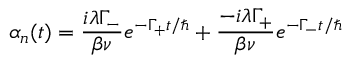<formula> <loc_0><loc_0><loc_500><loc_500>\alpha _ { n } ( t ) = \frac { i \lambda \Gamma _ { - } } { \beta \nu } e ^ { - \Gamma _ { + } t / } + \frac { - i \lambda \Gamma _ { + } } { \beta \nu } e ^ { - \Gamma _ { - } t / }</formula> 